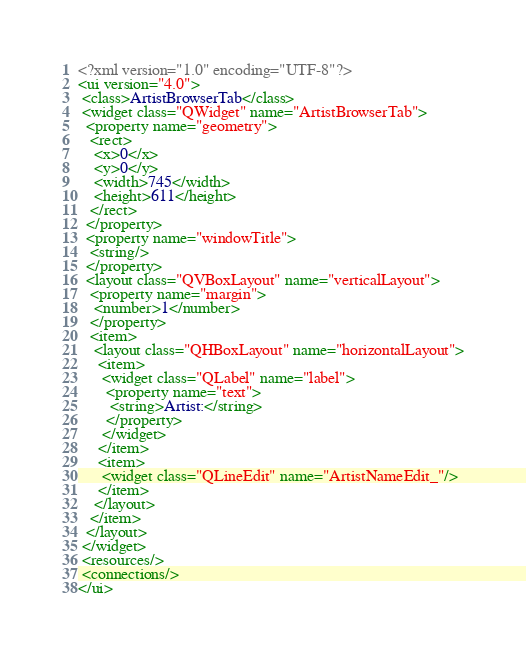Convert code to text. <code><loc_0><loc_0><loc_500><loc_500><_XML_><?xml version="1.0" encoding="UTF-8"?>
<ui version="4.0">
 <class>ArtistBrowserTab</class>
 <widget class="QWidget" name="ArtistBrowserTab">
  <property name="geometry">
   <rect>
    <x>0</x>
    <y>0</y>
    <width>745</width>
    <height>611</height>
   </rect>
  </property>
  <property name="windowTitle">
   <string/>
  </property>
  <layout class="QVBoxLayout" name="verticalLayout">
   <property name="margin">
    <number>1</number>
   </property>
   <item>
    <layout class="QHBoxLayout" name="horizontalLayout">
     <item>
      <widget class="QLabel" name="label">
       <property name="text">
        <string>Artist:</string>
       </property>
      </widget>
     </item>
     <item>
      <widget class="QLineEdit" name="ArtistNameEdit_"/>
     </item>
    </layout>
   </item>
  </layout>
 </widget>
 <resources/>
 <connections/>
</ui>
</code> 